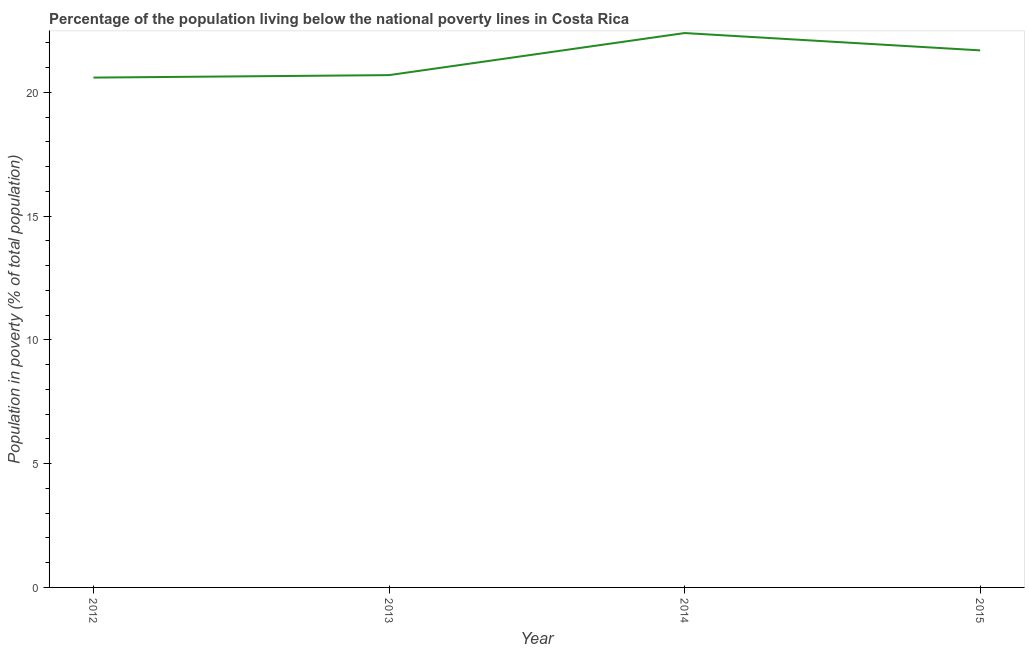What is the percentage of population living below poverty line in 2015?
Offer a terse response. 21.7. Across all years, what is the maximum percentage of population living below poverty line?
Offer a terse response. 22.4. Across all years, what is the minimum percentage of population living below poverty line?
Provide a short and direct response. 20.6. What is the sum of the percentage of population living below poverty line?
Give a very brief answer. 85.4. What is the difference between the percentage of population living below poverty line in 2013 and 2014?
Give a very brief answer. -1.7. What is the average percentage of population living below poverty line per year?
Provide a short and direct response. 21.35. What is the median percentage of population living below poverty line?
Offer a terse response. 21.2. In how many years, is the percentage of population living below poverty line greater than 17 %?
Make the answer very short. 4. What is the ratio of the percentage of population living below poverty line in 2012 to that in 2014?
Your response must be concise. 0.92. Is the percentage of population living below poverty line in 2012 less than that in 2013?
Your answer should be compact. Yes. What is the difference between the highest and the second highest percentage of population living below poverty line?
Provide a short and direct response. 0.7. Is the sum of the percentage of population living below poverty line in 2013 and 2015 greater than the maximum percentage of population living below poverty line across all years?
Keep it short and to the point. Yes. What is the difference between the highest and the lowest percentage of population living below poverty line?
Your answer should be very brief. 1.8. Does the percentage of population living below poverty line monotonically increase over the years?
Offer a terse response. No. Does the graph contain grids?
Your answer should be compact. No. What is the title of the graph?
Your response must be concise. Percentage of the population living below the national poverty lines in Costa Rica. What is the label or title of the X-axis?
Offer a very short reply. Year. What is the label or title of the Y-axis?
Provide a succinct answer. Population in poverty (% of total population). What is the Population in poverty (% of total population) of 2012?
Offer a terse response. 20.6. What is the Population in poverty (% of total population) of 2013?
Your answer should be very brief. 20.7. What is the Population in poverty (% of total population) of 2014?
Provide a short and direct response. 22.4. What is the Population in poverty (% of total population) in 2015?
Your answer should be very brief. 21.7. What is the difference between the Population in poverty (% of total population) in 2012 and 2014?
Your answer should be very brief. -1.8. What is the difference between the Population in poverty (% of total population) in 2012 and 2015?
Your answer should be very brief. -1.1. What is the difference between the Population in poverty (% of total population) in 2013 and 2014?
Provide a succinct answer. -1.7. What is the difference between the Population in poverty (% of total population) in 2013 and 2015?
Ensure brevity in your answer.  -1. What is the ratio of the Population in poverty (% of total population) in 2012 to that in 2013?
Provide a short and direct response. 0.99. What is the ratio of the Population in poverty (% of total population) in 2012 to that in 2014?
Give a very brief answer. 0.92. What is the ratio of the Population in poverty (% of total population) in 2012 to that in 2015?
Make the answer very short. 0.95. What is the ratio of the Population in poverty (% of total population) in 2013 to that in 2014?
Provide a short and direct response. 0.92. What is the ratio of the Population in poverty (% of total population) in 2013 to that in 2015?
Give a very brief answer. 0.95. What is the ratio of the Population in poverty (% of total population) in 2014 to that in 2015?
Your response must be concise. 1.03. 